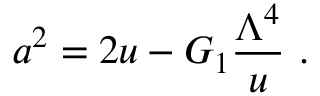Convert formula to latex. <formula><loc_0><loc_0><loc_500><loc_500>a ^ { 2 } = 2 u - G _ { 1 } { \frac { \Lambda ^ { 4 } } { u } } \ .</formula> 